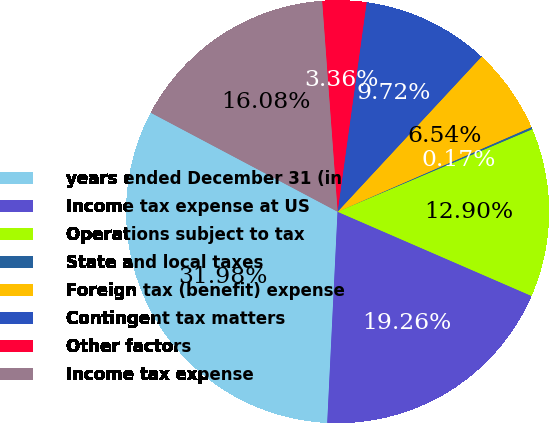Convert chart. <chart><loc_0><loc_0><loc_500><loc_500><pie_chart><fcel>years ended December 31 (in<fcel>Income tax expense at US<fcel>Operations subject to tax<fcel>State and local taxes<fcel>Foreign tax (benefit) expense<fcel>Contingent tax matters<fcel>Other factors<fcel>Income tax expense<nl><fcel>31.98%<fcel>19.26%<fcel>12.9%<fcel>0.17%<fcel>6.54%<fcel>9.72%<fcel>3.36%<fcel>16.08%<nl></chart> 